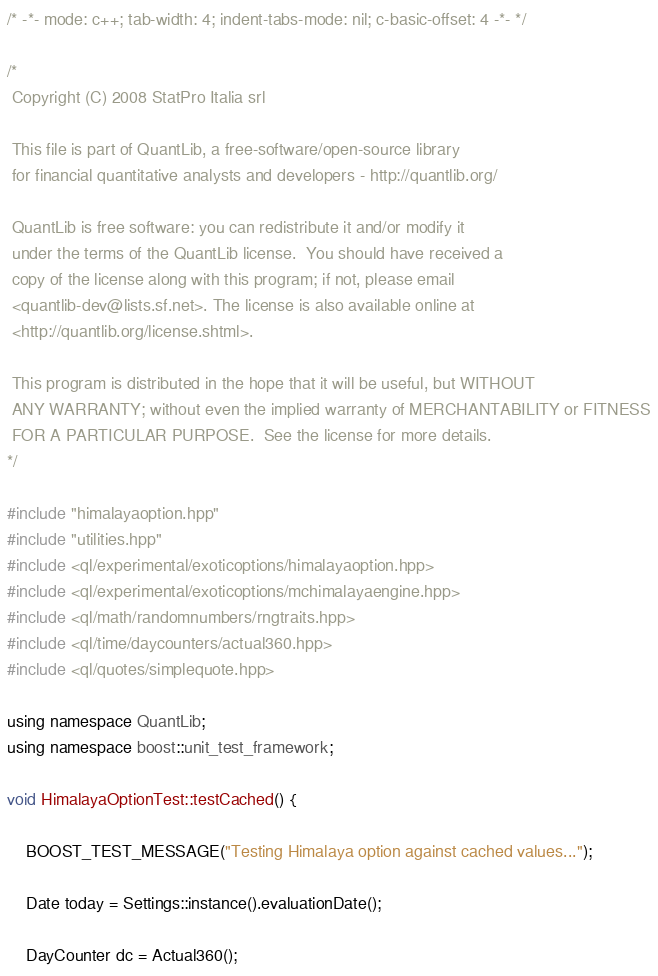Convert code to text. <code><loc_0><loc_0><loc_500><loc_500><_C++_>/* -*- mode: c++; tab-width: 4; indent-tabs-mode: nil; c-basic-offset: 4 -*- */

/*
 Copyright (C) 2008 StatPro Italia srl

 This file is part of QuantLib, a free-software/open-source library
 for financial quantitative analysts and developers - http://quantlib.org/

 QuantLib is free software: you can redistribute it and/or modify it
 under the terms of the QuantLib license.  You should have received a
 copy of the license along with this program; if not, please email
 <quantlib-dev@lists.sf.net>. The license is also available online at
 <http://quantlib.org/license.shtml>.

 This program is distributed in the hope that it will be useful, but WITHOUT
 ANY WARRANTY; without even the implied warranty of MERCHANTABILITY or FITNESS
 FOR A PARTICULAR PURPOSE.  See the license for more details.
*/

#include "himalayaoption.hpp"
#include "utilities.hpp"
#include <ql/experimental/exoticoptions/himalayaoption.hpp>
#include <ql/experimental/exoticoptions/mchimalayaengine.hpp>
#include <ql/math/randomnumbers/rngtraits.hpp>
#include <ql/time/daycounters/actual360.hpp>
#include <ql/quotes/simplequote.hpp>

using namespace QuantLib;
using namespace boost::unit_test_framework;

void HimalayaOptionTest::testCached() {

    BOOST_TEST_MESSAGE("Testing Himalaya option against cached values...");

    Date today = Settings::instance().evaluationDate();

    DayCounter dc = Actual360();</code> 